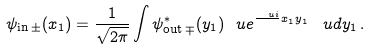Convert formula to latex. <formula><loc_0><loc_0><loc_500><loc_500>\psi _ { \text {in} \, \pm } ( x _ { 1 } ) = \frac { 1 } { \sqrt { 2 \pi } } \int { \psi } _ { \text {out} \, \mp } ^ { * } ( y _ { 1 } ) \ u e ^ { \frac { \ u i } { } x _ { 1 } y _ { 1 } } \, \ u d y _ { 1 } \, .</formula> 